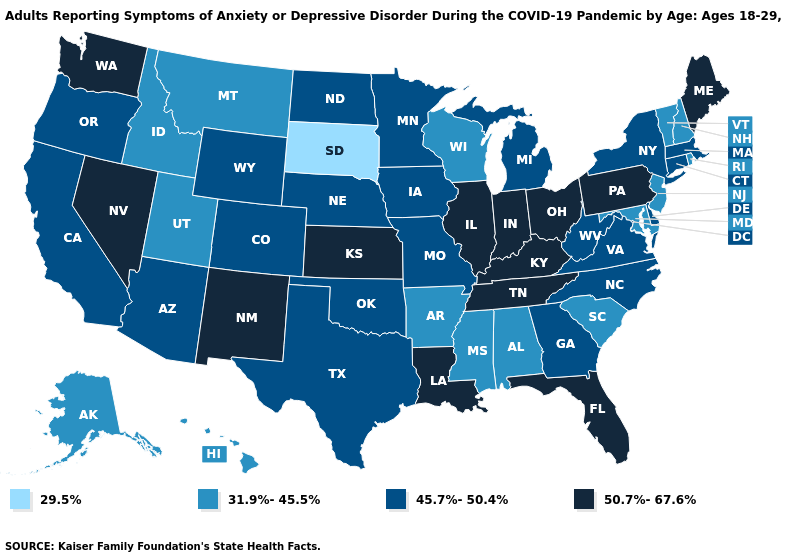Name the states that have a value in the range 50.7%-67.6%?
Quick response, please. Florida, Illinois, Indiana, Kansas, Kentucky, Louisiana, Maine, Nevada, New Mexico, Ohio, Pennsylvania, Tennessee, Washington. Name the states that have a value in the range 50.7%-67.6%?
Keep it brief. Florida, Illinois, Indiana, Kansas, Kentucky, Louisiana, Maine, Nevada, New Mexico, Ohio, Pennsylvania, Tennessee, Washington. Which states have the lowest value in the USA?
Quick response, please. South Dakota. Name the states that have a value in the range 45.7%-50.4%?
Be succinct. Arizona, California, Colorado, Connecticut, Delaware, Georgia, Iowa, Massachusetts, Michigan, Minnesota, Missouri, Nebraska, New York, North Carolina, North Dakota, Oklahoma, Oregon, Texas, Virginia, West Virginia, Wyoming. How many symbols are there in the legend?
Be succinct. 4. Does West Virginia have a higher value than Illinois?
Write a very short answer. No. Does New Jersey have the lowest value in the Northeast?
Quick response, please. Yes. Does South Dakota have the lowest value in the MidWest?
Be succinct. Yes. Does Ohio have the same value as Washington?
Be succinct. Yes. Name the states that have a value in the range 50.7%-67.6%?
Quick response, please. Florida, Illinois, Indiana, Kansas, Kentucky, Louisiana, Maine, Nevada, New Mexico, Ohio, Pennsylvania, Tennessee, Washington. Does Washington have the lowest value in the USA?
Be succinct. No. What is the value of Alaska?
Short answer required. 31.9%-45.5%. Name the states that have a value in the range 45.7%-50.4%?
Write a very short answer. Arizona, California, Colorado, Connecticut, Delaware, Georgia, Iowa, Massachusetts, Michigan, Minnesota, Missouri, Nebraska, New York, North Carolina, North Dakota, Oklahoma, Oregon, Texas, Virginia, West Virginia, Wyoming. Name the states that have a value in the range 45.7%-50.4%?
Concise answer only. Arizona, California, Colorado, Connecticut, Delaware, Georgia, Iowa, Massachusetts, Michigan, Minnesota, Missouri, Nebraska, New York, North Carolina, North Dakota, Oklahoma, Oregon, Texas, Virginia, West Virginia, Wyoming. 